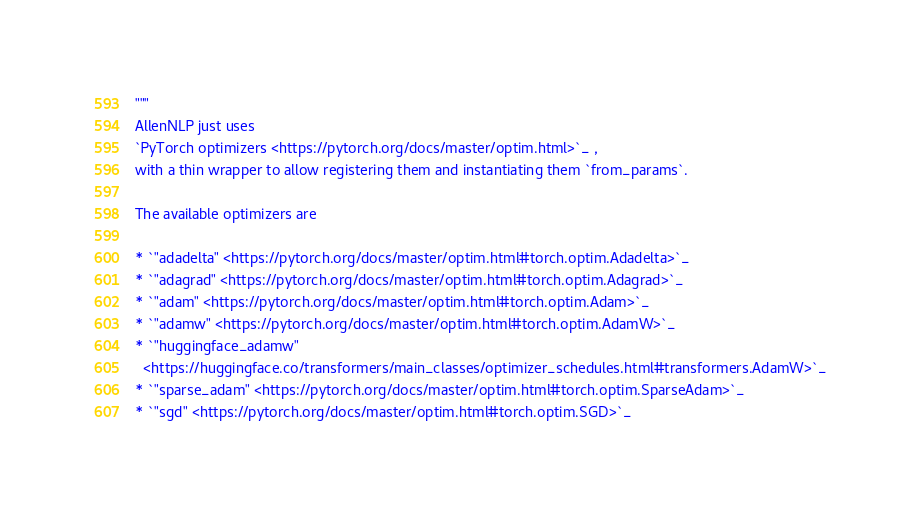Convert code to text. <code><loc_0><loc_0><loc_500><loc_500><_Python_>"""
AllenNLP just uses
`PyTorch optimizers <https://pytorch.org/docs/master/optim.html>`_ ,
with a thin wrapper to allow registering them and instantiating them `from_params`.

The available optimizers are

* `"adadelta" <https://pytorch.org/docs/master/optim.html#torch.optim.Adadelta>`_
* `"adagrad" <https://pytorch.org/docs/master/optim.html#torch.optim.Adagrad>`_
* `"adam" <https://pytorch.org/docs/master/optim.html#torch.optim.Adam>`_
* `"adamw" <https://pytorch.org/docs/master/optim.html#torch.optim.AdamW>`_
* `"huggingface_adamw"
  <https://huggingface.co/transformers/main_classes/optimizer_schedules.html#transformers.AdamW>`_
* `"sparse_adam" <https://pytorch.org/docs/master/optim.html#torch.optim.SparseAdam>`_
* `"sgd" <https://pytorch.org/docs/master/optim.html#torch.optim.SGD>`_</code> 